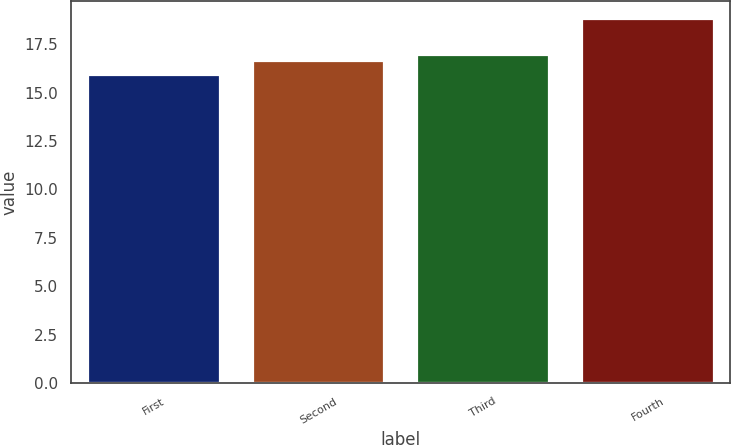Convert chart to OTSL. <chart><loc_0><loc_0><loc_500><loc_500><bar_chart><fcel>First<fcel>Second<fcel>Third<fcel>Fourth<nl><fcel>15.93<fcel>16.63<fcel>16.92<fcel>18.8<nl></chart> 